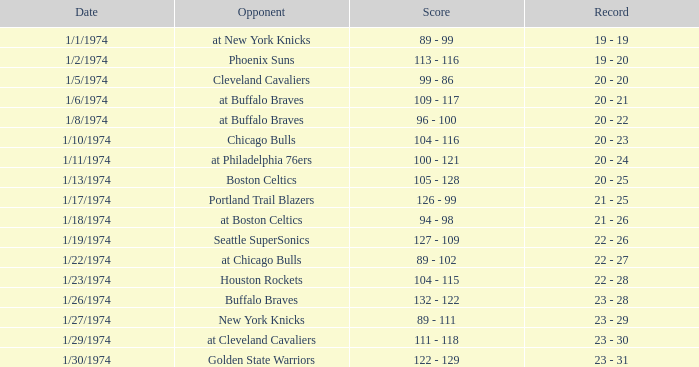What was the score on 1/10/1974? 104 - 116. 